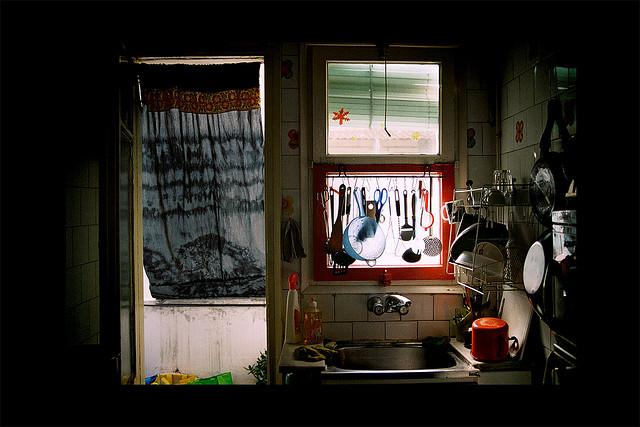What is hanging in the window?
Concise answer only. Utensils. What is in the window?
Give a very brief answer. Utensils. Are there any food items pictured?
Concise answer only. No. Are the curtains closed?
Keep it brief. Yes. What is hanging on the wall to the left of the windows?
Keep it brief. Curtain. What time does the clock show?
Keep it brief. No clock. How is the room heated?
Short answer required. Stove. Do you see a clock?
Keep it brief. No. 